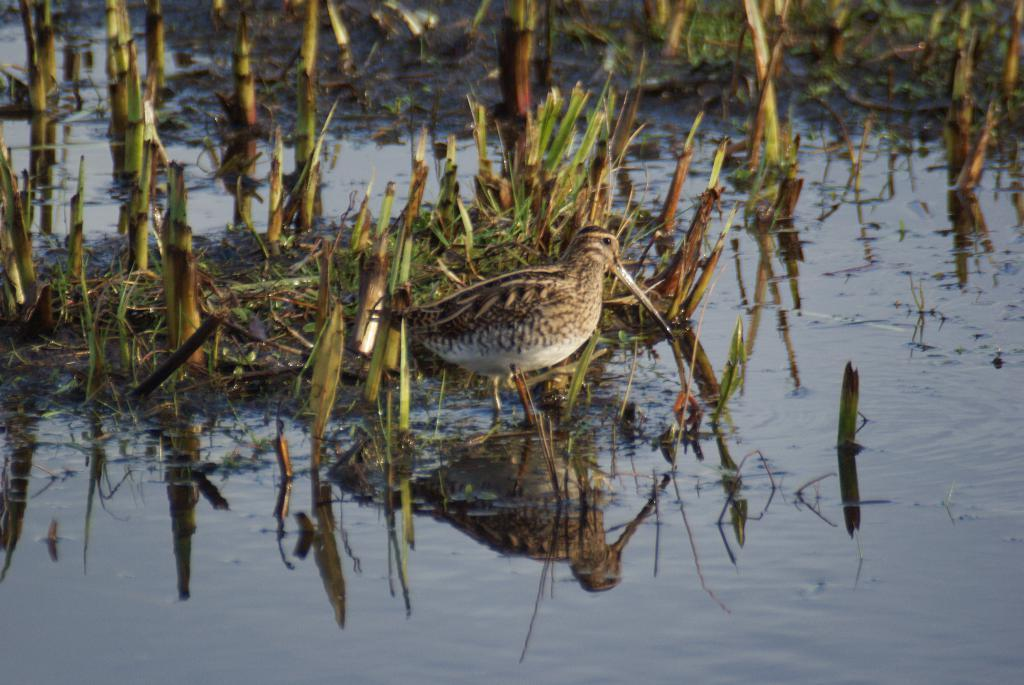What is the main subject of the image? There is a bird standing in the center of the image. What can be seen in the background of the image? There are plants in the background of the image. What is visible in the front of the image? There is water visible in the front of the image. What type of shirt is the bird wearing in the image? Birds do not wear shirts, so this detail cannot be found in the image. 